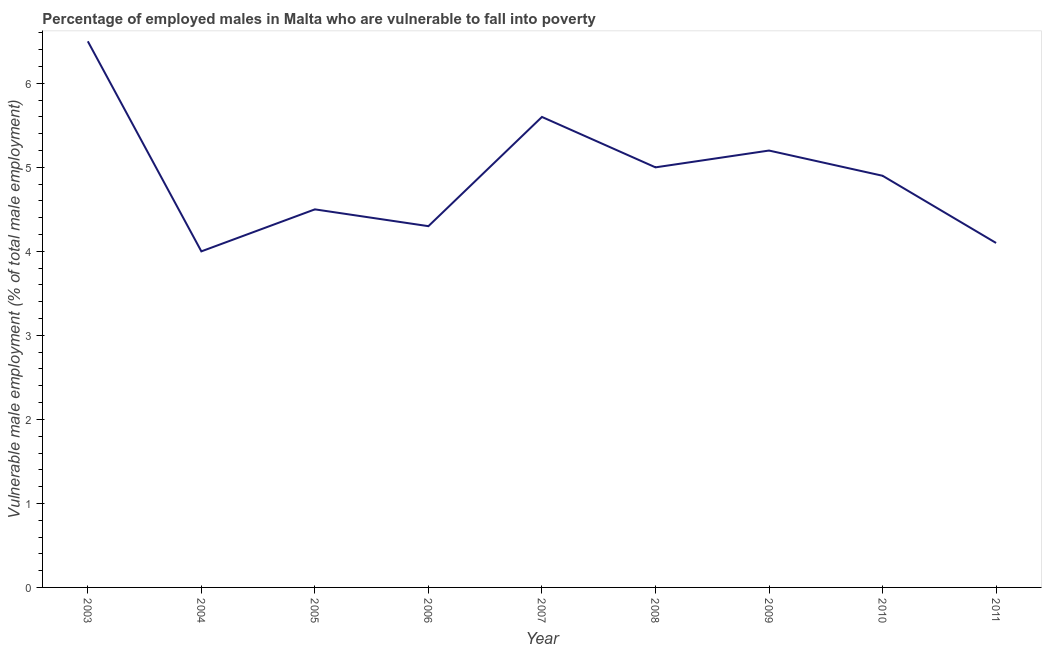What is the percentage of employed males who are vulnerable to fall into poverty in 2007?
Your response must be concise. 5.6. Across all years, what is the maximum percentage of employed males who are vulnerable to fall into poverty?
Keep it short and to the point. 6.5. In which year was the percentage of employed males who are vulnerable to fall into poverty minimum?
Your answer should be very brief. 2004. What is the sum of the percentage of employed males who are vulnerable to fall into poverty?
Provide a short and direct response. 44.1. What is the difference between the percentage of employed males who are vulnerable to fall into poverty in 2003 and 2006?
Provide a short and direct response. 2.2. What is the average percentage of employed males who are vulnerable to fall into poverty per year?
Your response must be concise. 4.9. What is the median percentage of employed males who are vulnerable to fall into poverty?
Your answer should be compact. 4.9. What is the ratio of the percentage of employed males who are vulnerable to fall into poverty in 2006 to that in 2010?
Provide a short and direct response. 0.88. Is the percentage of employed males who are vulnerable to fall into poverty in 2005 less than that in 2007?
Your answer should be very brief. Yes. What is the difference between the highest and the second highest percentage of employed males who are vulnerable to fall into poverty?
Keep it short and to the point. 0.9. Is the sum of the percentage of employed males who are vulnerable to fall into poverty in 2003 and 2009 greater than the maximum percentage of employed males who are vulnerable to fall into poverty across all years?
Offer a very short reply. Yes. What is the difference between the highest and the lowest percentage of employed males who are vulnerable to fall into poverty?
Offer a very short reply. 2.5. In how many years, is the percentage of employed males who are vulnerable to fall into poverty greater than the average percentage of employed males who are vulnerable to fall into poverty taken over all years?
Keep it short and to the point. 5. Does the percentage of employed males who are vulnerable to fall into poverty monotonically increase over the years?
Your response must be concise. No. Does the graph contain grids?
Offer a very short reply. No. What is the title of the graph?
Your response must be concise. Percentage of employed males in Malta who are vulnerable to fall into poverty. What is the label or title of the Y-axis?
Your answer should be compact. Vulnerable male employment (% of total male employment). What is the Vulnerable male employment (% of total male employment) in 2003?
Make the answer very short. 6.5. What is the Vulnerable male employment (% of total male employment) of 2005?
Give a very brief answer. 4.5. What is the Vulnerable male employment (% of total male employment) in 2006?
Your answer should be very brief. 4.3. What is the Vulnerable male employment (% of total male employment) of 2007?
Your answer should be compact. 5.6. What is the Vulnerable male employment (% of total male employment) in 2009?
Offer a very short reply. 5.2. What is the Vulnerable male employment (% of total male employment) in 2010?
Keep it short and to the point. 4.9. What is the Vulnerable male employment (% of total male employment) of 2011?
Your answer should be compact. 4.1. What is the difference between the Vulnerable male employment (% of total male employment) in 2003 and 2004?
Your answer should be very brief. 2.5. What is the difference between the Vulnerable male employment (% of total male employment) in 2003 and 2009?
Keep it short and to the point. 1.3. What is the difference between the Vulnerable male employment (% of total male employment) in 2003 and 2011?
Your answer should be compact. 2.4. What is the difference between the Vulnerable male employment (% of total male employment) in 2004 and 2005?
Keep it short and to the point. -0.5. What is the difference between the Vulnerable male employment (% of total male employment) in 2004 and 2006?
Ensure brevity in your answer.  -0.3. What is the difference between the Vulnerable male employment (% of total male employment) in 2004 and 2007?
Provide a succinct answer. -1.6. What is the difference between the Vulnerable male employment (% of total male employment) in 2005 and 2007?
Offer a terse response. -1.1. What is the difference between the Vulnerable male employment (% of total male employment) in 2005 and 2010?
Make the answer very short. -0.4. What is the difference between the Vulnerable male employment (% of total male employment) in 2006 and 2007?
Give a very brief answer. -1.3. What is the difference between the Vulnerable male employment (% of total male employment) in 2006 and 2008?
Give a very brief answer. -0.7. What is the difference between the Vulnerable male employment (% of total male employment) in 2006 and 2009?
Provide a short and direct response. -0.9. What is the difference between the Vulnerable male employment (% of total male employment) in 2006 and 2010?
Make the answer very short. -0.6. What is the difference between the Vulnerable male employment (% of total male employment) in 2006 and 2011?
Provide a short and direct response. 0.2. What is the difference between the Vulnerable male employment (% of total male employment) in 2007 and 2008?
Your answer should be very brief. 0.6. What is the difference between the Vulnerable male employment (% of total male employment) in 2008 and 2009?
Keep it short and to the point. -0.2. What is the difference between the Vulnerable male employment (% of total male employment) in 2009 and 2010?
Give a very brief answer. 0.3. What is the ratio of the Vulnerable male employment (% of total male employment) in 2003 to that in 2004?
Your answer should be very brief. 1.62. What is the ratio of the Vulnerable male employment (% of total male employment) in 2003 to that in 2005?
Make the answer very short. 1.44. What is the ratio of the Vulnerable male employment (% of total male employment) in 2003 to that in 2006?
Offer a terse response. 1.51. What is the ratio of the Vulnerable male employment (% of total male employment) in 2003 to that in 2007?
Make the answer very short. 1.16. What is the ratio of the Vulnerable male employment (% of total male employment) in 2003 to that in 2009?
Give a very brief answer. 1.25. What is the ratio of the Vulnerable male employment (% of total male employment) in 2003 to that in 2010?
Give a very brief answer. 1.33. What is the ratio of the Vulnerable male employment (% of total male employment) in 2003 to that in 2011?
Offer a very short reply. 1.58. What is the ratio of the Vulnerable male employment (% of total male employment) in 2004 to that in 2005?
Provide a succinct answer. 0.89. What is the ratio of the Vulnerable male employment (% of total male employment) in 2004 to that in 2007?
Provide a succinct answer. 0.71. What is the ratio of the Vulnerable male employment (% of total male employment) in 2004 to that in 2009?
Ensure brevity in your answer.  0.77. What is the ratio of the Vulnerable male employment (% of total male employment) in 2004 to that in 2010?
Your answer should be compact. 0.82. What is the ratio of the Vulnerable male employment (% of total male employment) in 2004 to that in 2011?
Give a very brief answer. 0.98. What is the ratio of the Vulnerable male employment (% of total male employment) in 2005 to that in 2006?
Your answer should be very brief. 1.05. What is the ratio of the Vulnerable male employment (% of total male employment) in 2005 to that in 2007?
Your answer should be very brief. 0.8. What is the ratio of the Vulnerable male employment (% of total male employment) in 2005 to that in 2009?
Offer a terse response. 0.86. What is the ratio of the Vulnerable male employment (% of total male employment) in 2005 to that in 2010?
Your answer should be compact. 0.92. What is the ratio of the Vulnerable male employment (% of total male employment) in 2005 to that in 2011?
Offer a terse response. 1.1. What is the ratio of the Vulnerable male employment (% of total male employment) in 2006 to that in 2007?
Your response must be concise. 0.77. What is the ratio of the Vulnerable male employment (% of total male employment) in 2006 to that in 2008?
Provide a succinct answer. 0.86. What is the ratio of the Vulnerable male employment (% of total male employment) in 2006 to that in 2009?
Your answer should be compact. 0.83. What is the ratio of the Vulnerable male employment (% of total male employment) in 2006 to that in 2010?
Keep it short and to the point. 0.88. What is the ratio of the Vulnerable male employment (% of total male employment) in 2006 to that in 2011?
Your answer should be very brief. 1.05. What is the ratio of the Vulnerable male employment (% of total male employment) in 2007 to that in 2008?
Ensure brevity in your answer.  1.12. What is the ratio of the Vulnerable male employment (% of total male employment) in 2007 to that in 2009?
Keep it short and to the point. 1.08. What is the ratio of the Vulnerable male employment (% of total male employment) in 2007 to that in 2010?
Provide a short and direct response. 1.14. What is the ratio of the Vulnerable male employment (% of total male employment) in 2007 to that in 2011?
Keep it short and to the point. 1.37. What is the ratio of the Vulnerable male employment (% of total male employment) in 2008 to that in 2009?
Offer a terse response. 0.96. What is the ratio of the Vulnerable male employment (% of total male employment) in 2008 to that in 2010?
Give a very brief answer. 1.02. What is the ratio of the Vulnerable male employment (% of total male employment) in 2008 to that in 2011?
Keep it short and to the point. 1.22. What is the ratio of the Vulnerable male employment (% of total male employment) in 2009 to that in 2010?
Keep it short and to the point. 1.06. What is the ratio of the Vulnerable male employment (% of total male employment) in 2009 to that in 2011?
Keep it short and to the point. 1.27. What is the ratio of the Vulnerable male employment (% of total male employment) in 2010 to that in 2011?
Your answer should be very brief. 1.2. 